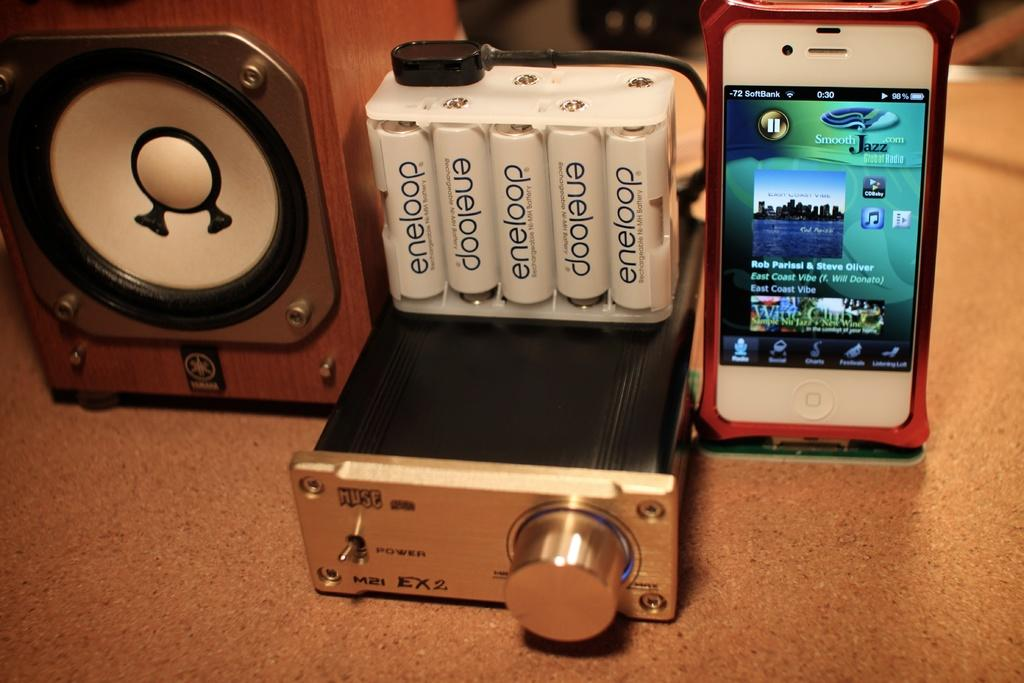<image>
Describe the image concisely. Eneloop batteries are sitting on top of a radio switch box, between a phone and a speaker. 